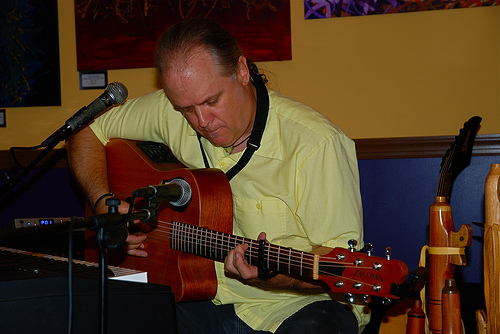<image>
Is there a man on the violin? No. The man is not positioned on the violin. They may be near each other, but the man is not supported by or resting on top of the violin. 